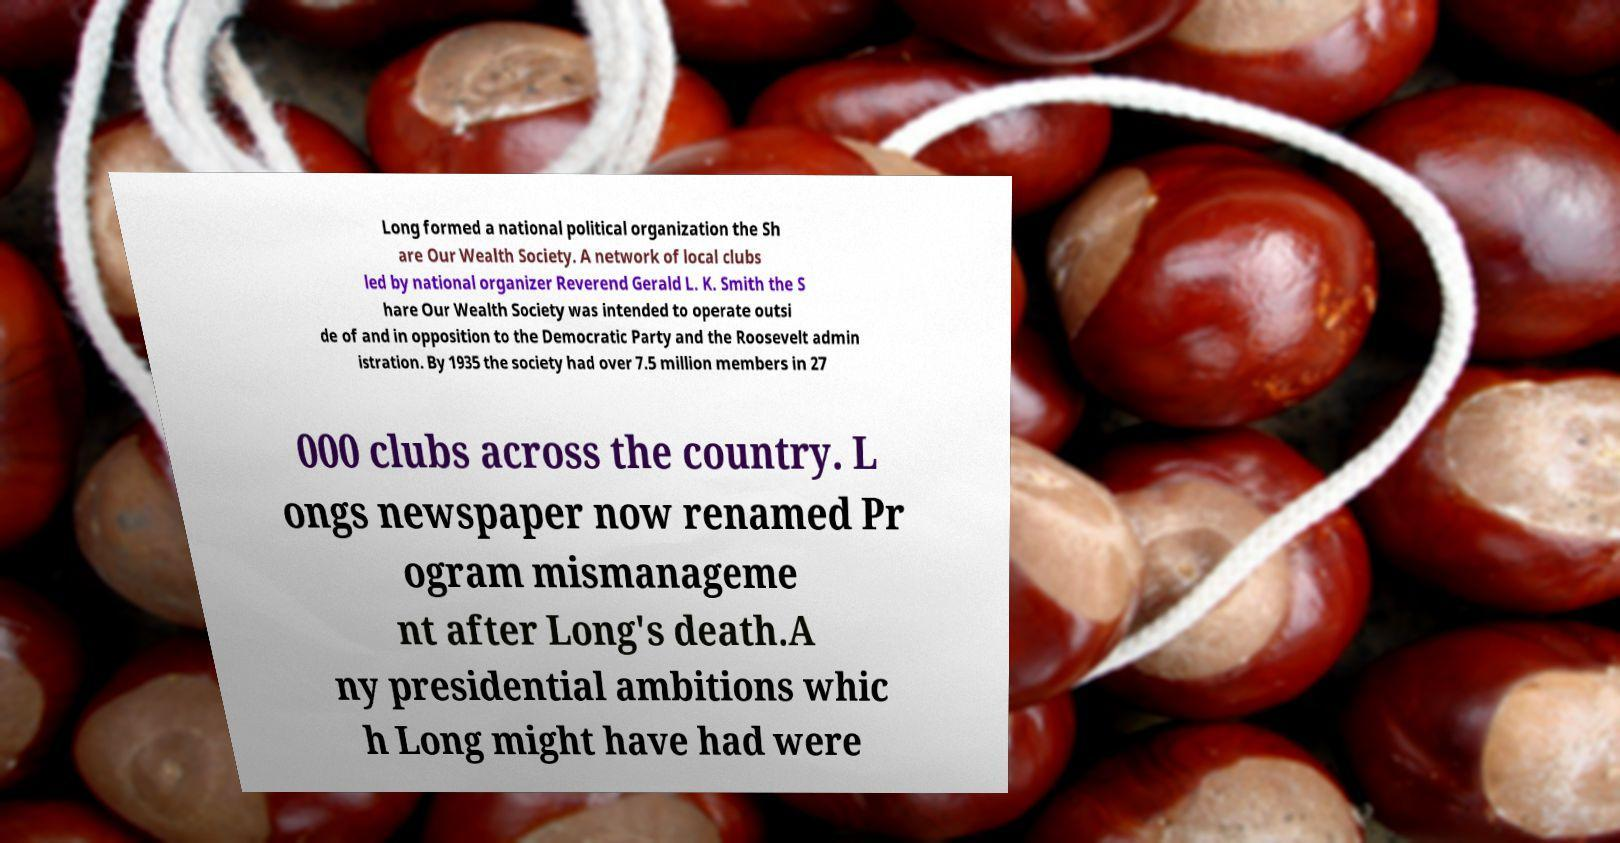There's text embedded in this image that I need extracted. Can you transcribe it verbatim? Long formed a national political organization the Sh are Our Wealth Society. A network of local clubs led by national organizer Reverend Gerald L. K. Smith the S hare Our Wealth Society was intended to operate outsi de of and in opposition to the Democratic Party and the Roosevelt admin istration. By 1935 the society had over 7.5 million members in 27 000 clubs across the country. L ongs newspaper now renamed Pr ogram mismanageme nt after Long's death.A ny presidential ambitions whic h Long might have had were 